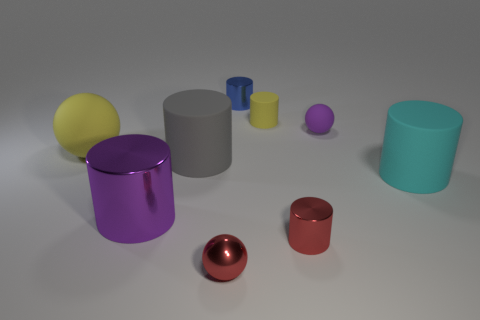Do the big purple thing and the tiny shiny object that is behind the cyan cylinder have the same shape?
Offer a terse response. Yes. Are there any yellow spheres right of the large purple shiny object?
Your response must be concise. No. There is a small cylinder that is the same color as the metal ball; what is it made of?
Ensure brevity in your answer.  Metal. What number of cylinders are either big cyan objects or brown shiny things?
Make the answer very short. 1. Is the large gray thing the same shape as the tiny purple rubber thing?
Offer a terse response. No. What size is the purple thing that is in front of the large cyan cylinder?
Offer a terse response. Large. Are there any small metal balls that have the same color as the large ball?
Keep it short and to the point. No. There is a red metal thing that is behind the red metal ball; does it have the same size as the tiny blue cylinder?
Ensure brevity in your answer.  Yes. The large matte ball has what color?
Provide a succinct answer. Yellow. What color is the tiny metallic object that is to the left of the metallic cylinder that is behind the small yellow rubber cylinder?
Your answer should be very brief. Red. 